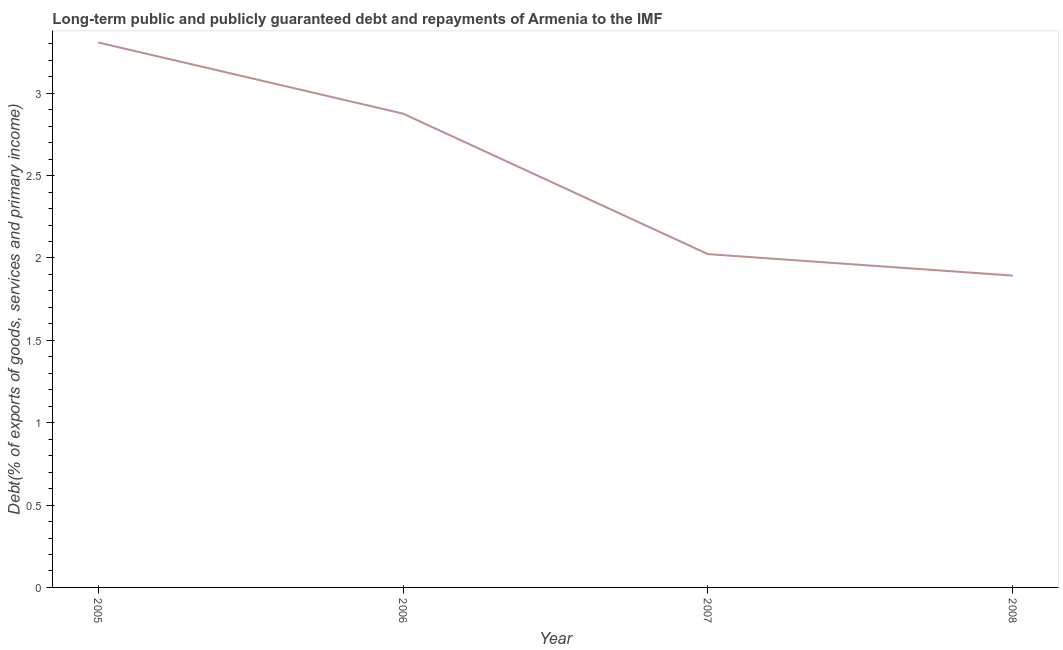What is the debt service in 2005?
Ensure brevity in your answer.  3.31. Across all years, what is the maximum debt service?
Make the answer very short. 3.31. Across all years, what is the minimum debt service?
Provide a succinct answer. 1.89. What is the sum of the debt service?
Your answer should be compact. 10.1. What is the difference between the debt service in 2006 and 2007?
Give a very brief answer. 0.85. What is the average debt service per year?
Give a very brief answer. 2.53. What is the median debt service?
Your answer should be compact. 2.45. In how many years, is the debt service greater than 1.2 %?
Your response must be concise. 4. Do a majority of the years between 2006 and 2007 (inclusive) have debt service greater than 0.5 %?
Offer a terse response. Yes. What is the ratio of the debt service in 2007 to that in 2008?
Offer a very short reply. 1.07. Is the debt service in 2007 less than that in 2008?
Ensure brevity in your answer.  No. Is the difference between the debt service in 2006 and 2007 greater than the difference between any two years?
Offer a terse response. No. What is the difference between the highest and the second highest debt service?
Give a very brief answer. 0.43. What is the difference between the highest and the lowest debt service?
Your answer should be very brief. 1.42. How many years are there in the graph?
Provide a succinct answer. 4. Are the values on the major ticks of Y-axis written in scientific E-notation?
Your answer should be compact. No. Does the graph contain any zero values?
Provide a succinct answer. No. What is the title of the graph?
Your response must be concise. Long-term public and publicly guaranteed debt and repayments of Armenia to the IMF. What is the label or title of the Y-axis?
Make the answer very short. Debt(% of exports of goods, services and primary income). What is the Debt(% of exports of goods, services and primary income) in 2005?
Your answer should be compact. 3.31. What is the Debt(% of exports of goods, services and primary income) in 2006?
Offer a very short reply. 2.88. What is the Debt(% of exports of goods, services and primary income) in 2007?
Your response must be concise. 2.02. What is the Debt(% of exports of goods, services and primary income) in 2008?
Ensure brevity in your answer.  1.89. What is the difference between the Debt(% of exports of goods, services and primary income) in 2005 and 2006?
Give a very brief answer. 0.43. What is the difference between the Debt(% of exports of goods, services and primary income) in 2005 and 2007?
Ensure brevity in your answer.  1.28. What is the difference between the Debt(% of exports of goods, services and primary income) in 2005 and 2008?
Provide a succinct answer. 1.42. What is the difference between the Debt(% of exports of goods, services and primary income) in 2006 and 2007?
Provide a succinct answer. 0.85. What is the difference between the Debt(% of exports of goods, services and primary income) in 2006 and 2008?
Your response must be concise. 0.98. What is the difference between the Debt(% of exports of goods, services and primary income) in 2007 and 2008?
Provide a succinct answer. 0.13. What is the ratio of the Debt(% of exports of goods, services and primary income) in 2005 to that in 2006?
Offer a terse response. 1.15. What is the ratio of the Debt(% of exports of goods, services and primary income) in 2005 to that in 2007?
Your answer should be very brief. 1.64. What is the ratio of the Debt(% of exports of goods, services and primary income) in 2005 to that in 2008?
Give a very brief answer. 1.75. What is the ratio of the Debt(% of exports of goods, services and primary income) in 2006 to that in 2007?
Keep it short and to the point. 1.42. What is the ratio of the Debt(% of exports of goods, services and primary income) in 2006 to that in 2008?
Your response must be concise. 1.52. What is the ratio of the Debt(% of exports of goods, services and primary income) in 2007 to that in 2008?
Keep it short and to the point. 1.07. 